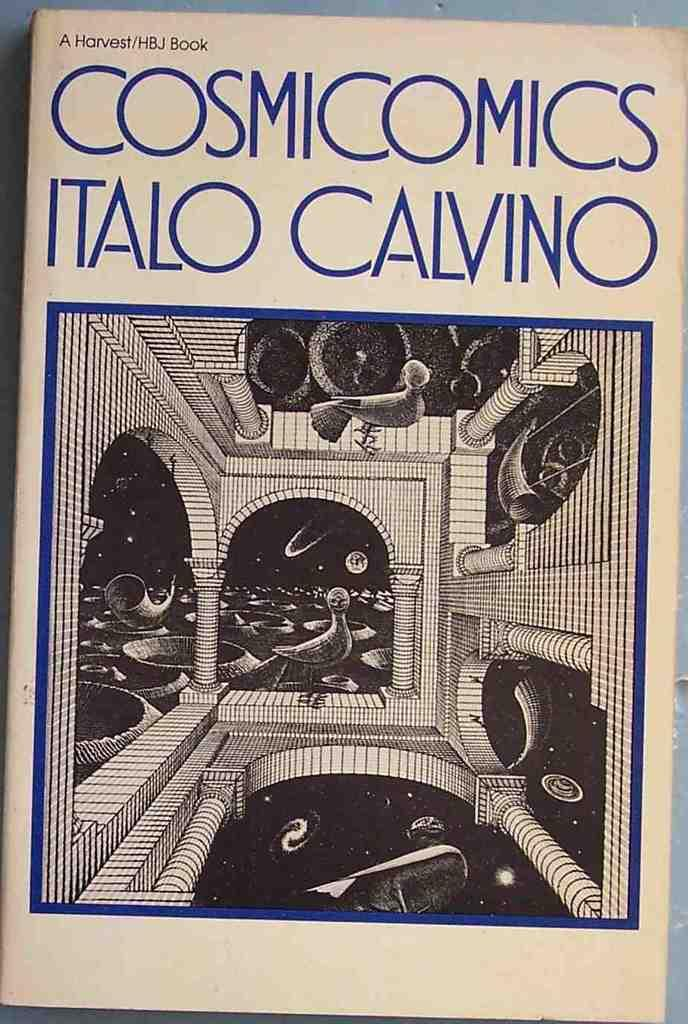<image>
Write a terse but informative summary of the picture. White book cover that says "Cosmicomics Italo Calvino" on it. 